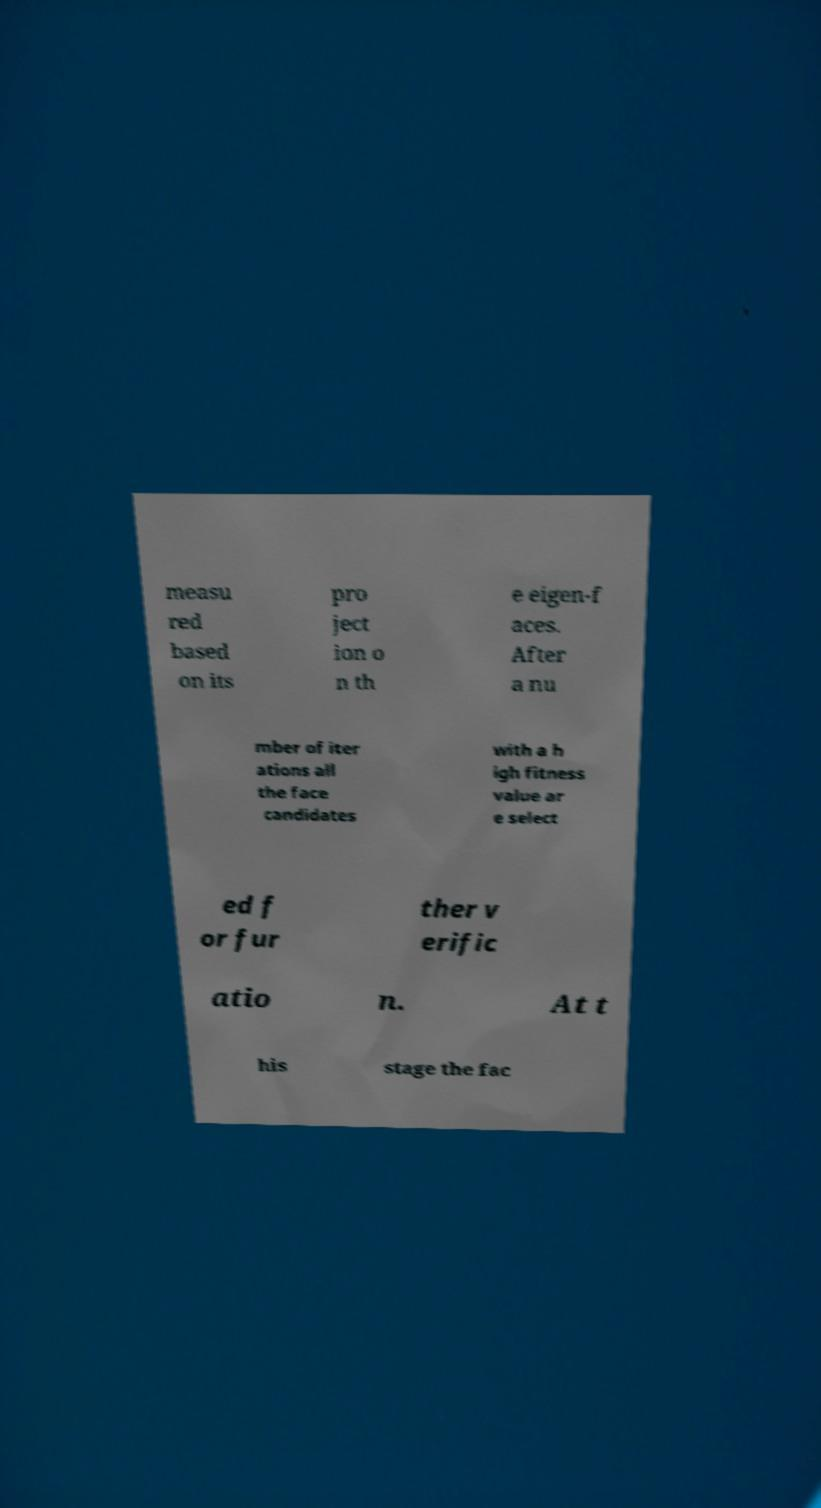For documentation purposes, I need the text within this image transcribed. Could you provide that? measu red based on its pro ject ion o n th e eigen-f aces. After a nu mber of iter ations all the face candidates with a h igh fitness value ar e select ed f or fur ther v erific atio n. At t his stage the fac 